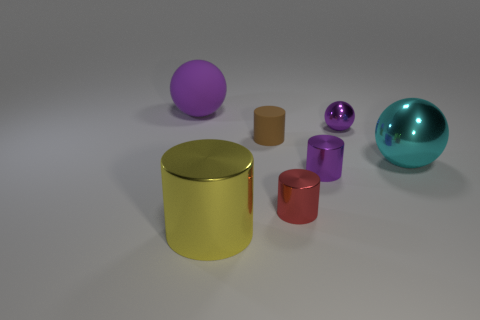Subtract all cyan balls. Subtract all cyan blocks. How many balls are left? 2 Add 2 large matte things. How many objects exist? 9 Subtract all cylinders. How many objects are left? 3 Add 2 cyan balls. How many cyan balls are left? 3 Add 1 purple things. How many purple things exist? 4 Subtract 0 yellow balls. How many objects are left? 7 Subtract all tiny blue cylinders. Subtract all tiny cylinders. How many objects are left? 4 